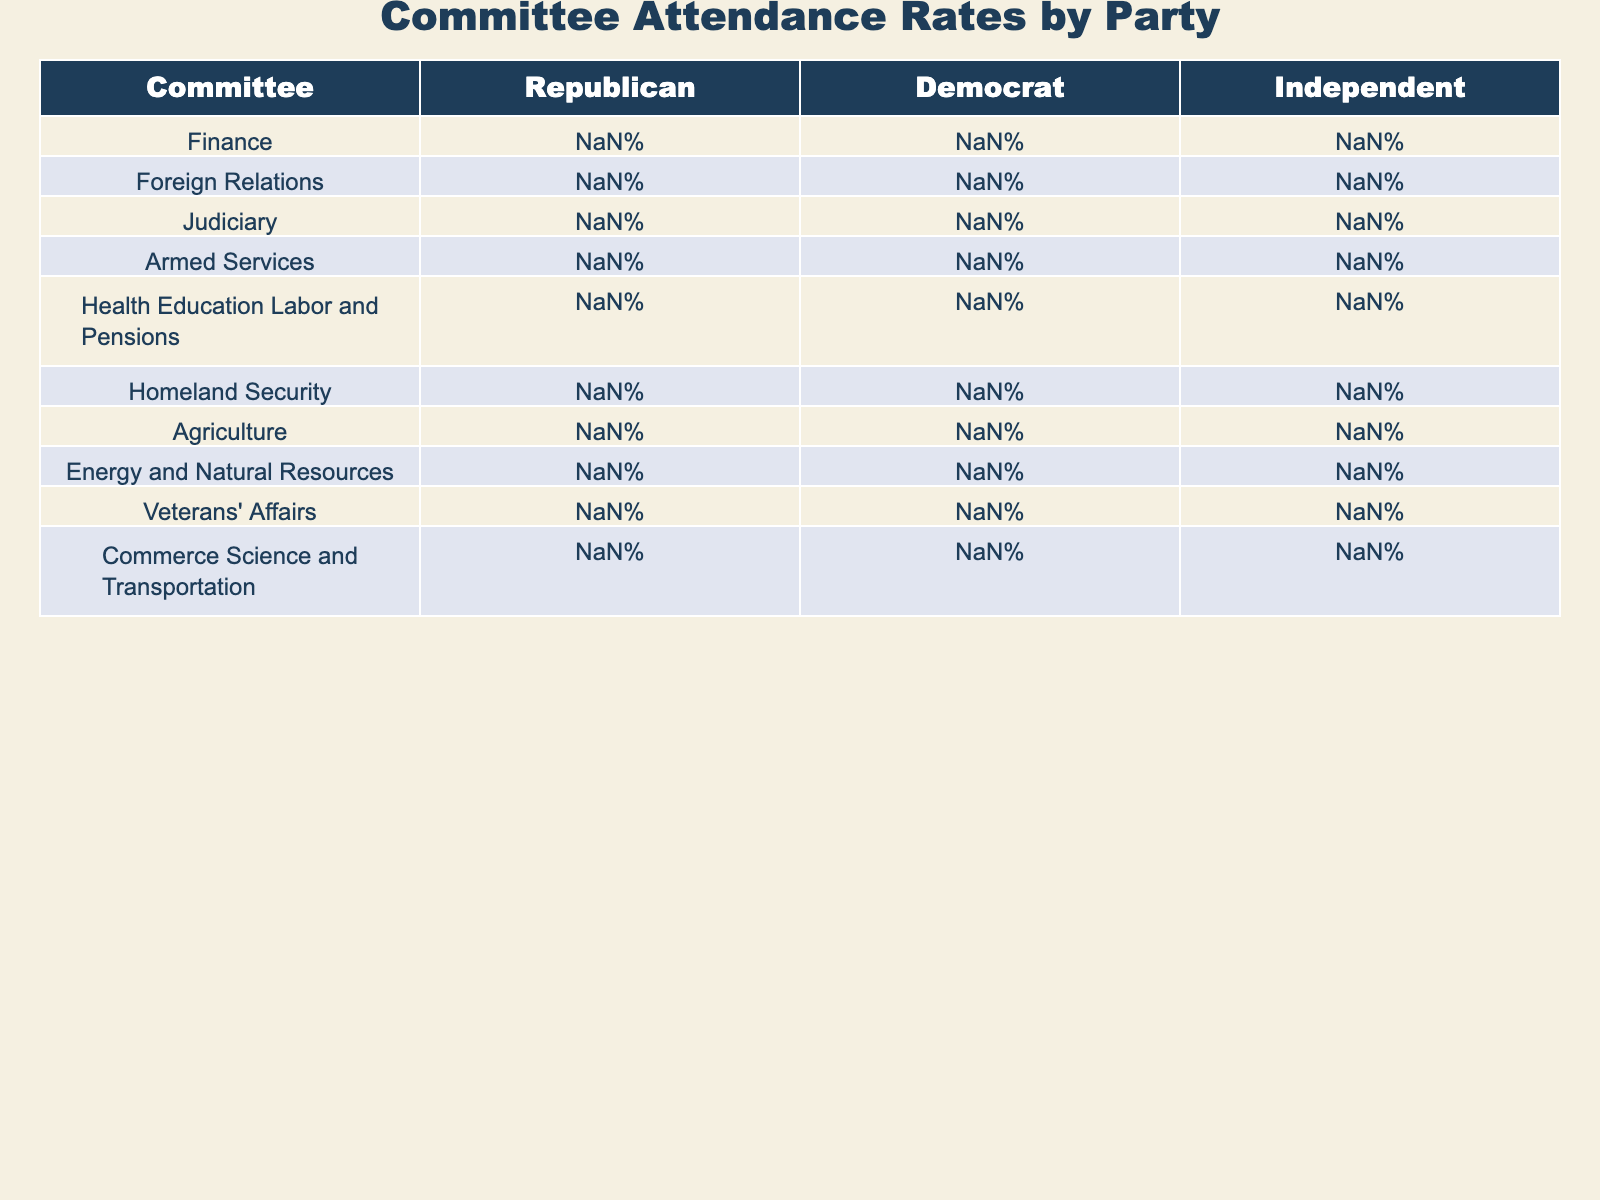What is the attendance rate for Republicans in the Armed Services Committee? The attendance rate for Republicans in the Armed Services Committee is listed directly in the table. It shows a rate of 96%.
Answer: 96% Which party has the highest attendance rate in the Judiciary Committee? The table shows the attendance rates for all parties in the Judiciary Committee. The Republicans have a rate of 94%, Democrats 93%, and Independents 91%. Therefore, Republicans have the highest attendance rate.
Answer: Republicans What is the difference in attendance rates between Democrats and Republicans in the Finance Committee? In the Finance Committee, Republicans have an attendance rate of 92% while Democrats have 88%. The difference is calculated as 92% - 88% = 4%.
Answer: 4% Which committee has the lowest attendance rate for Independents? The table shows the attendance rates for Independents across all committees. The lowest attendance rate for Independents is in the Agriculture Committee at 88%.
Answer: Agriculture Committee Is the attendance rate for Democrats in the Foreign Relations Committee above 90%? The attendance rate for Democrats in the Foreign Relations Committee is listed as 91%, which is above 90%. Therefore, the answer is yes.
Answer: Yes What is the average attendance rate for Democrats across all committees? To calculate the average attendance rate for Democrats, we sum the attendance rates (88% + 91% + 93% + 89% + 95% + 87% + 92% + 90% + 94% + 93%) and divide by 10. The sum is 909%, so the average is 909% / 10 = 90.9%.
Answer: 90.9% How do the attendance rates for Republicans in Health Education Labor and Pensions compare to that of Democrats in the same committee? In the Health Education Labor and Pensions Committee, Republicans have a rate of 88% and Democrats have 95%. Comparing these, Democrats have a higher attendance rate by 7%.
Answer: Democrats are higher by 7% Which party has the best overall attendance across all committees? To determine which party has the best overall attendance, we look for the highest attendance rates across all committees and then average them. Calculating, Republicans have 92.6%, Democrats have 90.3%, and Independents have 90.8%. The best overall attendance is thus for Republicans.
Answer: Republicans What percentage of attendance do both Independents and Democrats have in the Veterans' Affairs Committee? In the Veterans' Affairs Committee, Independents have an attendance rate of 96% and Democrats have a rate of 94%. The collective addition would be not directly relevant as they are separate, but both percentages are above 90%.
Answer: Independents: 96%, Democrats: 94% What is the highest attendance rate recorded in the table, and for which party and committee? Scanning across all entries in the table, the highest recorded attendance rate is 96% for Republicans in the Armed Services Committee.
Answer: 96%, Republicans, Armed Services Committee 